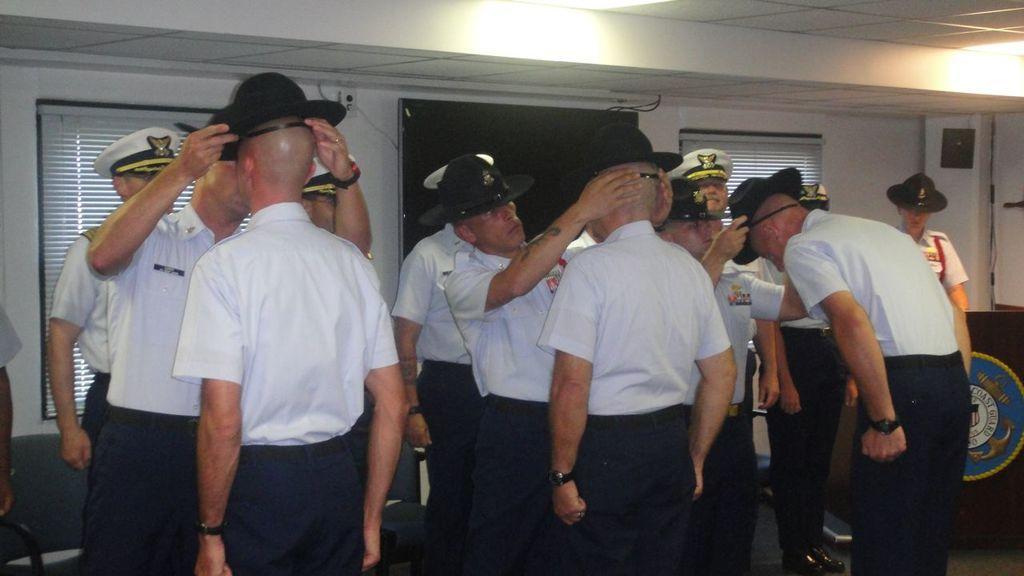Describe this image in one or two sentences. In this picture I see number of people who are standing in front and I see that all of them are wearing same uniform. In the background I see the wall and I see the lights on the ceiling. 